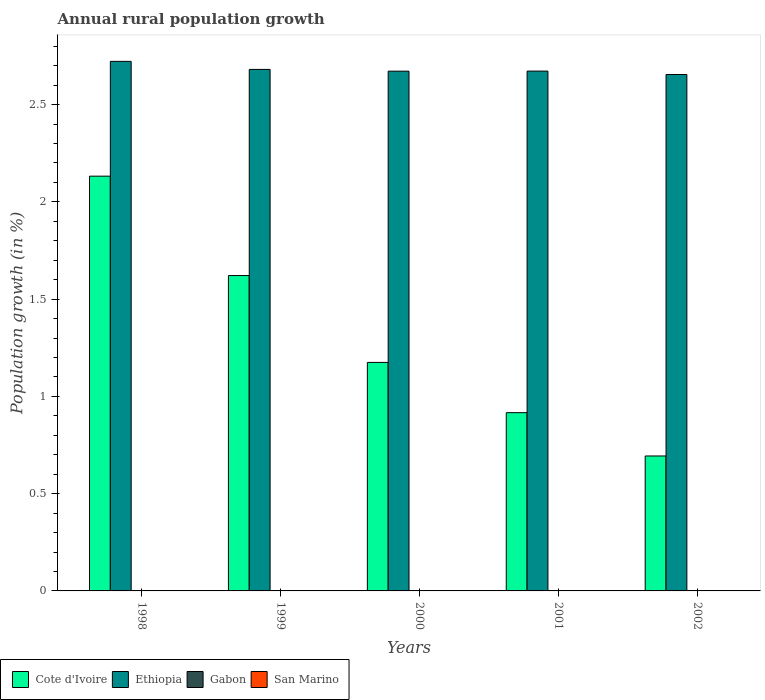How many groups of bars are there?
Your response must be concise. 5. How many bars are there on the 2nd tick from the left?
Make the answer very short. 2. What is the label of the 5th group of bars from the left?
Provide a short and direct response. 2002. What is the percentage of rural population growth in Cote d'Ivoire in 2001?
Ensure brevity in your answer.  0.92. Across all years, what is the maximum percentage of rural population growth in Cote d'Ivoire?
Keep it short and to the point. 2.13. In which year was the percentage of rural population growth in Ethiopia maximum?
Your answer should be compact. 1998. What is the total percentage of rural population growth in Ethiopia in the graph?
Give a very brief answer. 13.4. What is the difference between the percentage of rural population growth in Cote d'Ivoire in 1998 and that in 1999?
Give a very brief answer. 0.51. What is the difference between the percentage of rural population growth in Gabon in 1998 and the percentage of rural population growth in Ethiopia in 2001?
Offer a terse response. -2.67. What is the average percentage of rural population growth in Ethiopia per year?
Offer a very short reply. 2.68. In the year 1998, what is the difference between the percentage of rural population growth in Cote d'Ivoire and percentage of rural population growth in Ethiopia?
Your answer should be very brief. -0.59. In how many years, is the percentage of rural population growth in Gabon greater than 1.7 %?
Offer a terse response. 0. What is the ratio of the percentage of rural population growth in Cote d'Ivoire in 1999 to that in 2000?
Keep it short and to the point. 1.38. Is the difference between the percentage of rural population growth in Cote d'Ivoire in 1998 and 2001 greater than the difference between the percentage of rural population growth in Ethiopia in 1998 and 2001?
Your answer should be very brief. Yes. What is the difference between the highest and the second highest percentage of rural population growth in Ethiopia?
Make the answer very short. 0.04. What is the difference between the highest and the lowest percentage of rural population growth in Cote d'Ivoire?
Your answer should be compact. 1.44. Is it the case that in every year, the sum of the percentage of rural population growth in Cote d'Ivoire and percentage of rural population growth in Ethiopia is greater than the sum of percentage of rural population growth in San Marino and percentage of rural population growth in Gabon?
Make the answer very short. No. Is it the case that in every year, the sum of the percentage of rural population growth in San Marino and percentage of rural population growth in Cote d'Ivoire is greater than the percentage of rural population growth in Ethiopia?
Keep it short and to the point. No. How many years are there in the graph?
Your answer should be compact. 5. How many legend labels are there?
Give a very brief answer. 4. What is the title of the graph?
Offer a terse response. Annual rural population growth. What is the label or title of the X-axis?
Ensure brevity in your answer.  Years. What is the label or title of the Y-axis?
Provide a succinct answer. Population growth (in %). What is the Population growth (in %) in Cote d'Ivoire in 1998?
Provide a short and direct response. 2.13. What is the Population growth (in %) in Ethiopia in 1998?
Give a very brief answer. 2.72. What is the Population growth (in %) of Gabon in 1998?
Your response must be concise. 0. What is the Population growth (in %) in Cote d'Ivoire in 1999?
Your answer should be compact. 1.62. What is the Population growth (in %) of Ethiopia in 1999?
Give a very brief answer. 2.68. What is the Population growth (in %) in Cote d'Ivoire in 2000?
Offer a terse response. 1.17. What is the Population growth (in %) in Ethiopia in 2000?
Your answer should be compact. 2.67. What is the Population growth (in %) of San Marino in 2000?
Keep it short and to the point. 0. What is the Population growth (in %) in Cote d'Ivoire in 2001?
Provide a short and direct response. 0.92. What is the Population growth (in %) in Ethiopia in 2001?
Offer a very short reply. 2.67. What is the Population growth (in %) of Cote d'Ivoire in 2002?
Your response must be concise. 0.69. What is the Population growth (in %) of Ethiopia in 2002?
Offer a terse response. 2.65. Across all years, what is the maximum Population growth (in %) of Cote d'Ivoire?
Ensure brevity in your answer.  2.13. Across all years, what is the maximum Population growth (in %) of Ethiopia?
Provide a succinct answer. 2.72. Across all years, what is the minimum Population growth (in %) of Cote d'Ivoire?
Your answer should be very brief. 0.69. Across all years, what is the minimum Population growth (in %) of Ethiopia?
Offer a very short reply. 2.65. What is the total Population growth (in %) in Cote d'Ivoire in the graph?
Keep it short and to the point. 6.54. What is the total Population growth (in %) in Ethiopia in the graph?
Your answer should be compact. 13.4. What is the total Population growth (in %) of Gabon in the graph?
Your answer should be compact. 0. What is the difference between the Population growth (in %) in Cote d'Ivoire in 1998 and that in 1999?
Give a very brief answer. 0.51. What is the difference between the Population growth (in %) in Ethiopia in 1998 and that in 1999?
Ensure brevity in your answer.  0.04. What is the difference between the Population growth (in %) in Cote d'Ivoire in 1998 and that in 2000?
Give a very brief answer. 0.96. What is the difference between the Population growth (in %) of Ethiopia in 1998 and that in 2000?
Offer a terse response. 0.05. What is the difference between the Population growth (in %) in Cote d'Ivoire in 1998 and that in 2001?
Provide a succinct answer. 1.22. What is the difference between the Population growth (in %) of Ethiopia in 1998 and that in 2001?
Provide a short and direct response. 0.05. What is the difference between the Population growth (in %) of Cote d'Ivoire in 1998 and that in 2002?
Make the answer very short. 1.44. What is the difference between the Population growth (in %) in Ethiopia in 1998 and that in 2002?
Provide a short and direct response. 0.07. What is the difference between the Population growth (in %) of Cote d'Ivoire in 1999 and that in 2000?
Keep it short and to the point. 0.45. What is the difference between the Population growth (in %) in Ethiopia in 1999 and that in 2000?
Offer a very short reply. 0.01. What is the difference between the Population growth (in %) in Cote d'Ivoire in 1999 and that in 2001?
Provide a short and direct response. 0.7. What is the difference between the Population growth (in %) in Ethiopia in 1999 and that in 2001?
Ensure brevity in your answer.  0.01. What is the difference between the Population growth (in %) in Cote d'Ivoire in 1999 and that in 2002?
Your response must be concise. 0.93. What is the difference between the Population growth (in %) of Ethiopia in 1999 and that in 2002?
Your answer should be very brief. 0.03. What is the difference between the Population growth (in %) in Cote d'Ivoire in 2000 and that in 2001?
Ensure brevity in your answer.  0.26. What is the difference between the Population growth (in %) of Ethiopia in 2000 and that in 2001?
Your answer should be very brief. -0. What is the difference between the Population growth (in %) of Cote d'Ivoire in 2000 and that in 2002?
Give a very brief answer. 0.48. What is the difference between the Population growth (in %) in Ethiopia in 2000 and that in 2002?
Your answer should be compact. 0.02. What is the difference between the Population growth (in %) in Cote d'Ivoire in 2001 and that in 2002?
Ensure brevity in your answer.  0.22. What is the difference between the Population growth (in %) in Ethiopia in 2001 and that in 2002?
Ensure brevity in your answer.  0.02. What is the difference between the Population growth (in %) in Cote d'Ivoire in 1998 and the Population growth (in %) in Ethiopia in 1999?
Offer a very short reply. -0.55. What is the difference between the Population growth (in %) in Cote d'Ivoire in 1998 and the Population growth (in %) in Ethiopia in 2000?
Provide a succinct answer. -0.54. What is the difference between the Population growth (in %) of Cote d'Ivoire in 1998 and the Population growth (in %) of Ethiopia in 2001?
Keep it short and to the point. -0.54. What is the difference between the Population growth (in %) in Cote d'Ivoire in 1998 and the Population growth (in %) in Ethiopia in 2002?
Make the answer very short. -0.52. What is the difference between the Population growth (in %) of Cote d'Ivoire in 1999 and the Population growth (in %) of Ethiopia in 2000?
Keep it short and to the point. -1.05. What is the difference between the Population growth (in %) of Cote d'Ivoire in 1999 and the Population growth (in %) of Ethiopia in 2001?
Keep it short and to the point. -1.05. What is the difference between the Population growth (in %) in Cote d'Ivoire in 1999 and the Population growth (in %) in Ethiopia in 2002?
Provide a succinct answer. -1.03. What is the difference between the Population growth (in %) in Cote d'Ivoire in 2000 and the Population growth (in %) in Ethiopia in 2001?
Provide a succinct answer. -1.5. What is the difference between the Population growth (in %) in Cote d'Ivoire in 2000 and the Population growth (in %) in Ethiopia in 2002?
Your answer should be compact. -1.48. What is the difference between the Population growth (in %) in Cote d'Ivoire in 2001 and the Population growth (in %) in Ethiopia in 2002?
Offer a terse response. -1.74. What is the average Population growth (in %) of Cote d'Ivoire per year?
Offer a terse response. 1.31. What is the average Population growth (in %) in Ethiopia per year?
Keep it short and to the point. 2.68. What is the average Population growth (in %) in Gabon per year?
Your answer should be very brief. 0. What is the average Population growth (in %) of San Marino per year?
Provide a succinct answer. 0. In the year 1998, what is the difference between the Population growth (in %) of Cote d'Ivoire and Population growth (in %) of Ethiopia?
Your answer should be compact. -0.59. In the year 1999, what is the difference between the Population growth (in %) of Cote d'Ivoire and Population growth (in %) of Ethiopia?
Offer a very short reply. -1.06. In the year 2000, what is the difference between the Population growth (in %) of Cote d'Ivoire and Population growth (in %) of Ethiopia?
Provide a short and direct response. -1.5. In the year 2001, what is the difference between the Population growth (in %) of Cote d'Ivoire and Population growth (in %) of Ethiopia?
Ensure brevity in your answer.  -1.76. In the year 2002, what is the difference between the Population growth (in %) in Cote d'Ivoire and Population growth (in %) in Ethiopia?
Your response must be concise. -1.96. What is the ratio of the Population growth (in %) of Cote d'Ivoire in 1998 to that in 1999?
Your answer should be compact. 1.32. What is the ratio of the Population growth (in %) in Ethiopia in 1998 to that in 1999?
Your response must be concise. 1.02. What is the ratio of the Population growth (in %) in Cote d'Ivoire in 1998 to that in 2000?
Your response must be concise. 1.82. What is the ratio of the Population growth (in %) of Ethiopia in 1998 to that in 2000?
Your response must be concise. 1.02. What is the ratio of the Population growth (in %) in Cote d'Ivoire in 1998 to that in 2001?
Your response must be concise. 2.33. What is the ratio of the Population growth (in %) in Ethiopia in 1998 to that in 2001?
Provide a short and direct response. 1.02. What is the ratio of the Population growth (in %) in Cote d'Ivoire in 1998 to that in 2002?
Offer a terse response. 3.07. What is the ratio of the Population growth (in %) of Ethiopia in 1998 to that in 2002?
Your answer should be very brief. 1.03. What is the ratio of the Population growth (in %) of Cote d'Ivoire in 1999 to that in 2000?
Offer a terse response. 1.38. What is the ratio of the Population growth (in %) of Ethiopia in 1999 to that in 2000?
Provide a short and direct response. 1. What is the ratio of the Population growth (in %) in Cote d'Ivoire in 1999 to that in 2001?
Offer a very short reply. 1.77. What is the ratio of the Population growth (in %) in Cote d'Ivoire in 1999 to that in 2002?
Give a very brief answer. 2.34. What is the ratio of the Population growth (in %) of Ethiopia in 1999 to that in 2002?
Make the answer very short. 1.01. What is the ratio of the Population growth (in %) of Cote d'Ivoire in 2000 to that in 2001?
Offer a very short reply. 1.28. What is the ratio of the Population growth (in %) in Ethiopia in 2000 to that in 2001?
Offer a terse response. 1. What is the ratio of the Population growth (in %) in Cote d'Ivoire in 2000 to that in 2002?
Your answer should be compact. 1.69. What is the ratio of the Population growth (in %) of Ethiopia in 2000 to that in 2002?
Offer a very short reply. 1.01. What is the ratio of the Population growth (in %) of Cote d'Ivoire in 2001 to that in 2002?
Give a very brief answer. 1.32. What is the ratio of the Population growth (in %) of Ethiopia in 2001 to that in 2002?
Your answer should be very brief. 1.01. What is the difference between the highest and the second highest Population growth (in %) of Cote d'Ivoire?
Make the answer very short. 0.51. What is the difference between the highest and the second highest Population growth (in %) in Ethiopia?
Ensure brevity in your answer.  0.04. What is the difference between the highest and the lowest Population growth (in %) in Cote d'Ivoire?
Ensure brevity in your answer.  1.44. What is the difference between the highest and the lowest Population growth (in %) of Ethiopia?
Give a very brief answer. 0.07. 